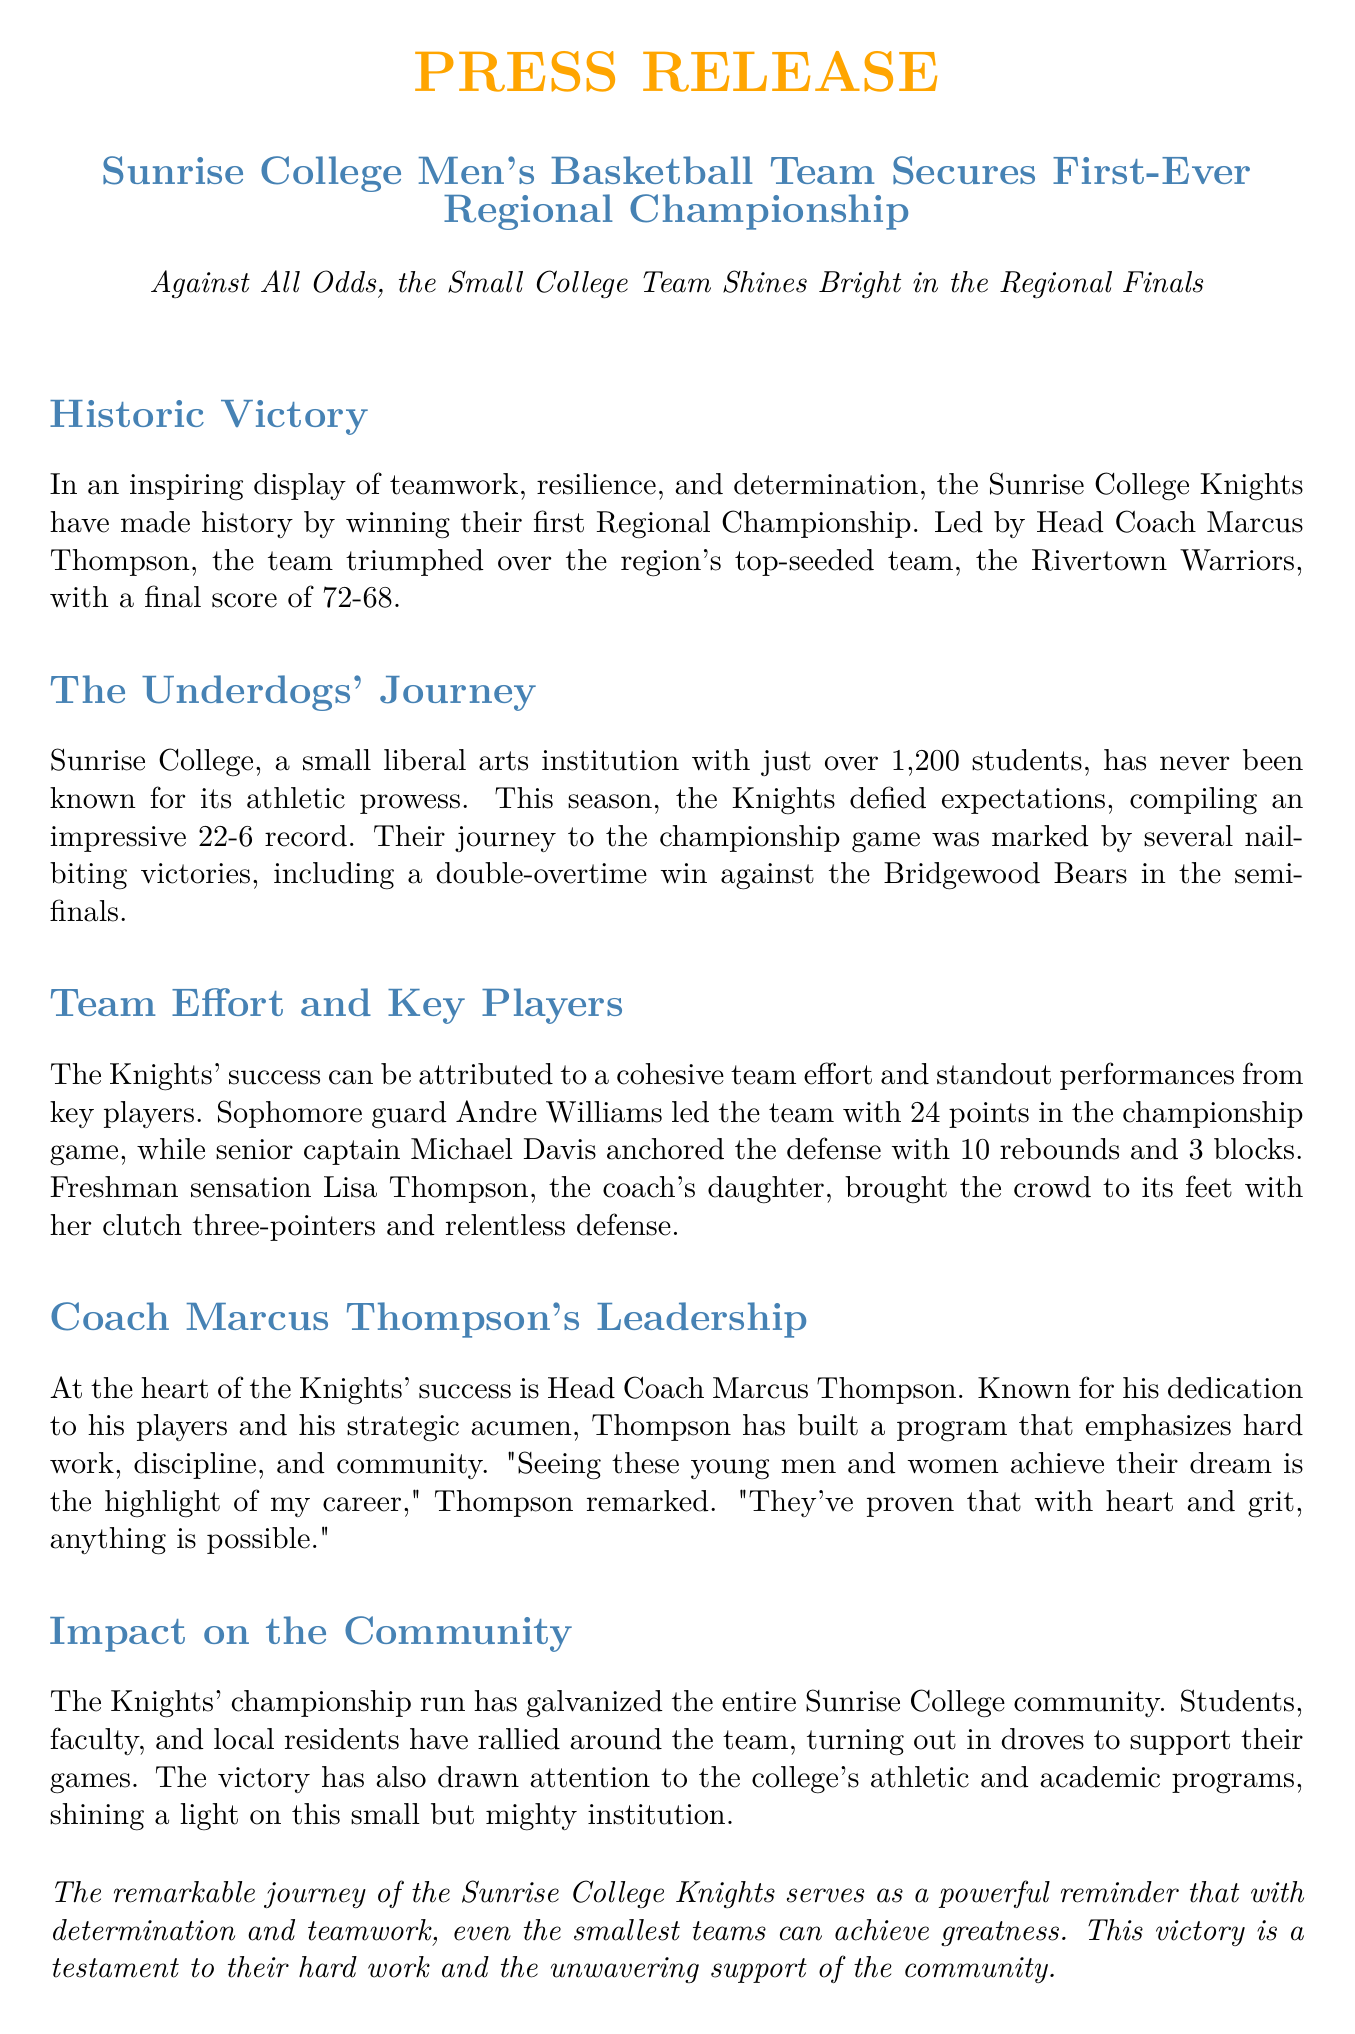What was the final score of the championship game? The final score reflects the result of the championship game played between the Sunrise College Knights and the Rivertown Warriors, which was 72-68.
Answer: 72-68 Who led the Knights in scoring during the championship game? The question asks for the top scorer of the Knights in the championship game, which was outlined in the document, naming Andre Williams as the player with 24 points.
Answer: Andre Williams What was the team's overall record for the season? The overall record of the Sunrise College Knights for the season is indicated in the document as 22 wins and 6 losses.
Answer: 22-6 How many rebounds did Michael Davis have in the championship game? The document specifies that senior captain Michael Davis contributed 10 rebounds during the championship game, which is the answer to this question.
Answer: 10 rebounds What significant victory did the Knights achieve in the semi-finals? This question seeks to identify a notable game that the Knights played before the championship, with the document highlighting a double-overtime win against the Bridgewood Bears.
Answer: Double-overtime win against the Bridgewood Bears Who is the head coach of the Sunrise College Knights? This question asks for the name of the individuals overseeing the team's coaching, which is stated in the document as Marcus Thompson.
Answer: Marcus Thompson What impact did the Knights' victory have on the Sunrise College community? The question looks for information regarding the community's reaction and support, which the document describes as rallying in droves around the team, showcasing community unity.
Answer: Galvanized the community What does Coach Marcus Thompson emphasize in his coaching program? This asks for the principles Coach Thompson prioritizes in his management strategy for the team, which are defined as hard work, discipline, and community in the document.
Answer: Hard work, discipline, and community 